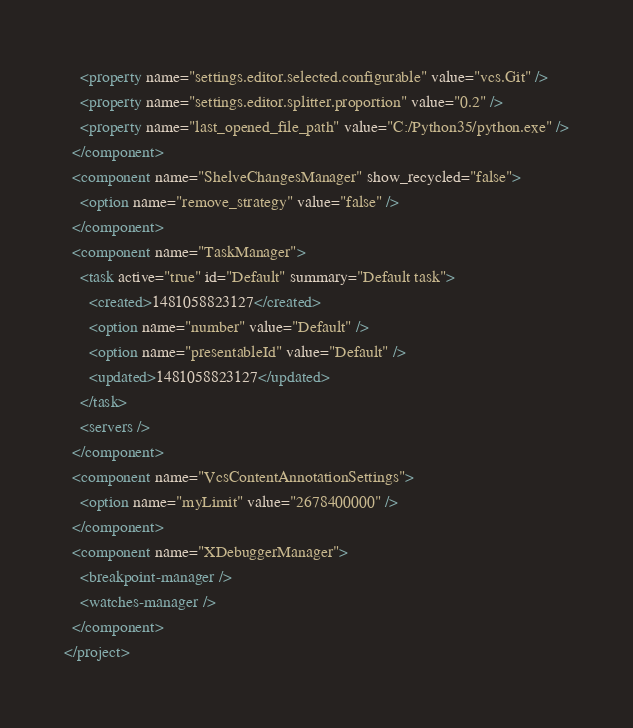<code> <loc_0><loc_0><loc_500><loc_500><_XML_>    <property name="settings.editor.selected.configurable" value="vcs.Git" />
    <property name="settings.editor.splitter.proportion" value="0.2" />
    <property name="last_opened_file_path" value="C:/Python35/python.exe" />
  </component>
  <component name="ShelveChangesManager" show_recycled="false">
    <option name="remove_strategy" value="false" />
  </component>
  <component name="TaskManager">
    <task active="true" id="Default" summary="Default task">
      <created>1481058823127</created>
      <option name="number" value="Default" />
      <option name="presentableId" value="Default" />
      <updated>1481058823127</updated>
    </task>
    <servers />
  </component>
  <component name="VcsContentAnnotationSettings">
    <option name="myLimit" value="2678400000" />
  </component>
  <component name="XDebuggerManager">
    <breakpoint-manager />
    <watches-manager />
  </component>
</project></code> 